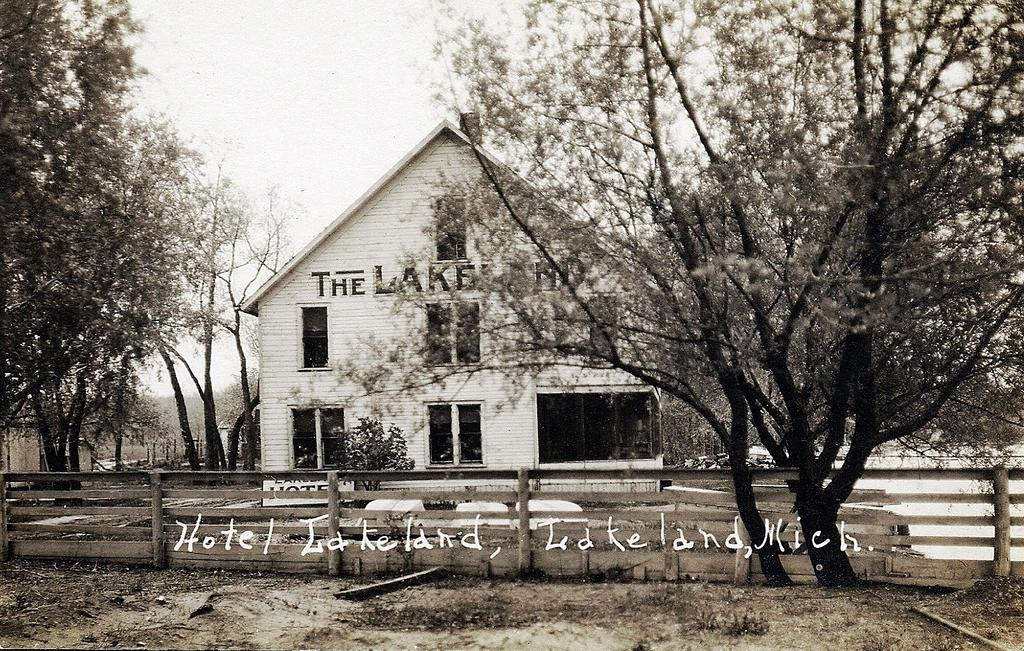<image>
Write a terse but informative summary of the picture. A sepia filer photo of a home by trees with the words Hotel Lakeland, Lakeland Mich. written over the photo 